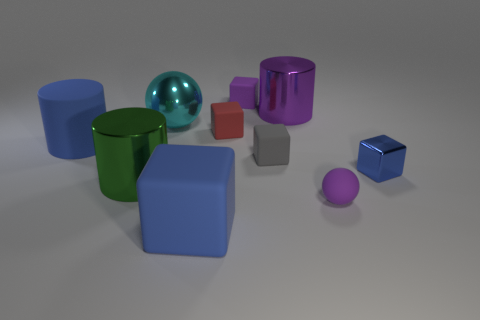What material is the purple cylinder?
Ensure brevity in your answer.  Metal. What material is the ball behind the large green metal object in front of the metallic cylinder right of the cyan object made of?
Offer a terse response. Metal. There is a blue cylinder behind the tiny gray cube; does it have the same size as the green thing that is to the left of the tiny ball?
Your answer should be compact. Yes. How many other objects are the same material as the small gray block?
Your answer should be very brief. 5. What number of shiny objects are green cylinders or tiny blue objects?
Ensure brevity in your answer.  2. Is the number of green shiny cylinders less than the number of tiny gray rubber cylinders?
Provide a succinct answer. No. Do the red matte cube and the blue object that is in front of the green shiny thing have the same size?
Offer a very short reply. No. Is there any other thing that has the same shape as the small red thing?
Your answer should be very brief. Yes. The cyan shiny thing is what size?
Ensure brevity in your answer.  Large. Are there fewer tiny gray rubber objects behind the purple matte ball than red rubber cylinders?
Give a very brief answer. No. 